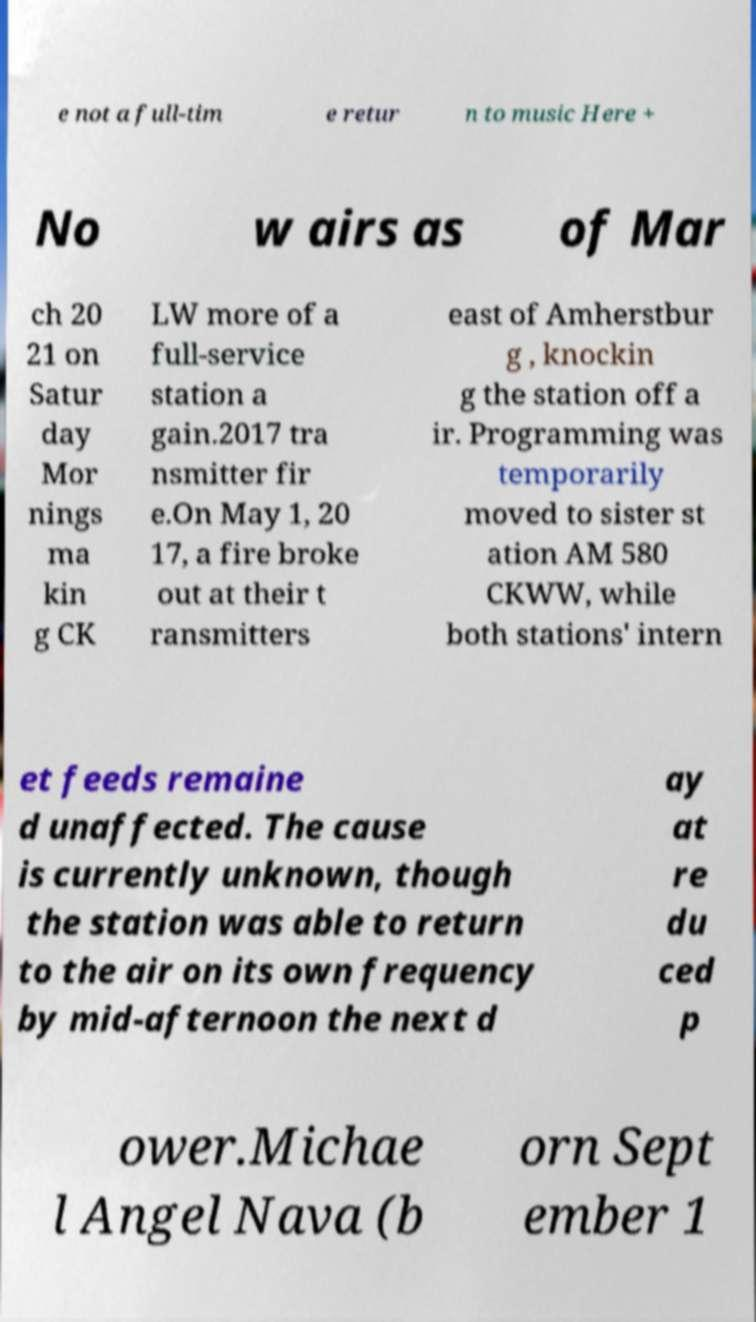Could you assist in decoding the text presented in this image and type it out clearly? e not a full-tim e retur n to music Here + No w airs as of Mar ch 20 21 on Satur day Mor nings ma kin g CK LW more of a full-service station a gain.2017 tra nsmitter fir e.On May 1, 20 17, a fire broke out at their t ransmitters east of Amherstbur g , knockin g the station off a ir. Programming was temporarily moved to sister st ation AM 580 CKWW, while both stations' intern et feeds remaine d unaffected. The cause is currently unknown, though the station was able to return to the air on its own frequency by mid-afternoon the next d ay at re du ced p ower.Michae l Angel Nava (b orn Sept ember 1 